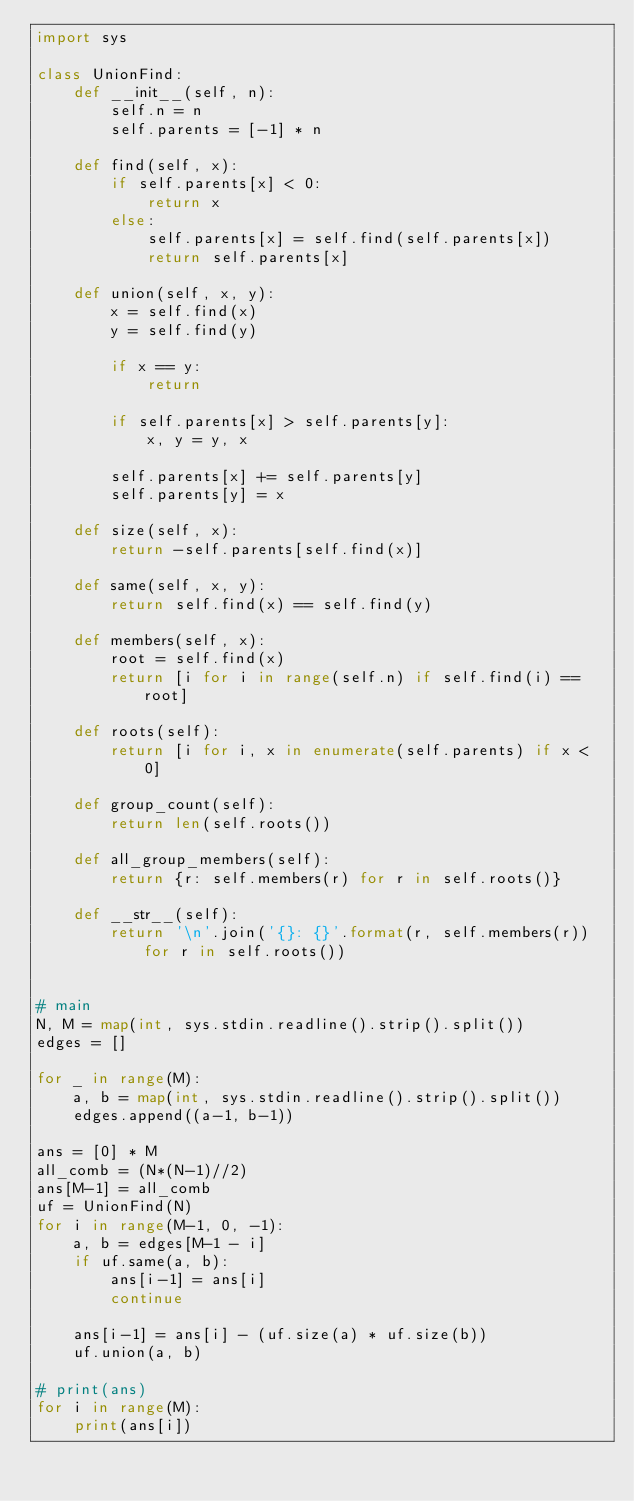Convert code to text. <code><loc_0><loc_0><loc_500><loc_500><_Python_>import sys

class UnionFind:
    def __init__(self, n):
        self.n = n
        self.parents = [-1] * n

    def find(self, x):
        if self.parents[x] < 0:
            return x
        else:
            self.parents[x] = self.find(self.parents[x])
            return self.parents[x]

    def union(self, x, y):
        x = self.find(x)
        y = self.find(y)

        if x == y:
            return

        if self.parents[x] > self.parents[y]:
            x, y = y, x

        self.parents[x] += self.parents[y]
        self.parents[y] = x

    def size(self, x):
        return -self.parents[self.find(x)]

    def same(self, x, y):
        return self.find(x) == self.find(y)

    def members(self, x):
        root = self.find(x)
        return [i for i in range(self.n) if self.find(i) == root]

    def roots(self):
        return [i for i, x in enumerate(self.parents) if x < 0]

    def group_count(self):
        return len(self.roots())

    def all_group_members(self):
        return {r: self.members(r) for r in self.roots()}

    def __str__(self):
        return '\n'.join('{}: {}'.format(r, self.members(r)) for r in self.roots())


# main
N, M = map(int, sys.stdin.readline().strip().split())
edges = []

for _ in range(M):
	a, b = map(int, sys.stdin.readline().strip().split())
	edges.append((a-1, b-1))

ans = [0] * M
all_comb = (N*(N-1)//2)
ans[M-1] = all_comb
uf = UnionFind(N)
for i in range(M-1, 0, -1):
    a, b = edges[M-1 - i]
    if uf.same(a, b):
        ans[i-1] = ans[i]
        continue

    ans[i-1] = ans[i] - (uf.size(a) * uf.size(b))
    uf.union(a, b)

# print(ans)
for i in range(M):
    print(ans[i])</code> 